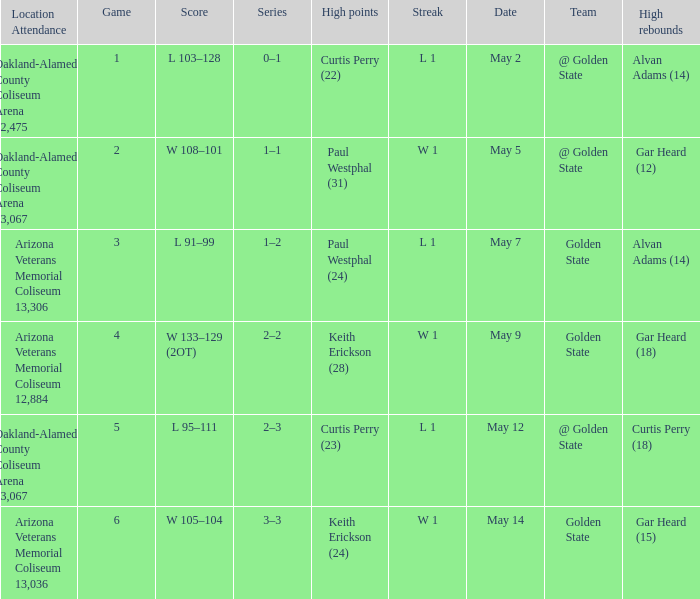How many games had they won or lost in a row on May 9? W 1. 